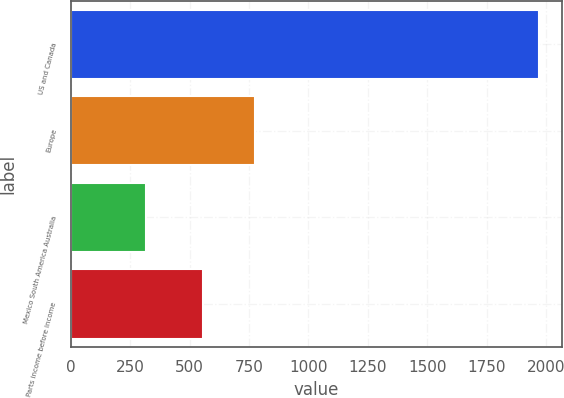<chart> <loc_0><loc_0><loc_500><loc_500><bar_chart><fcel>US and Canada<fcel>Europe<fcel>Mexico South America Australia<fcel>Parts income before income<nl><fcel>1969.4<fcel>773.9<fcel>316.8<fcel>555.6<nl></chart> 